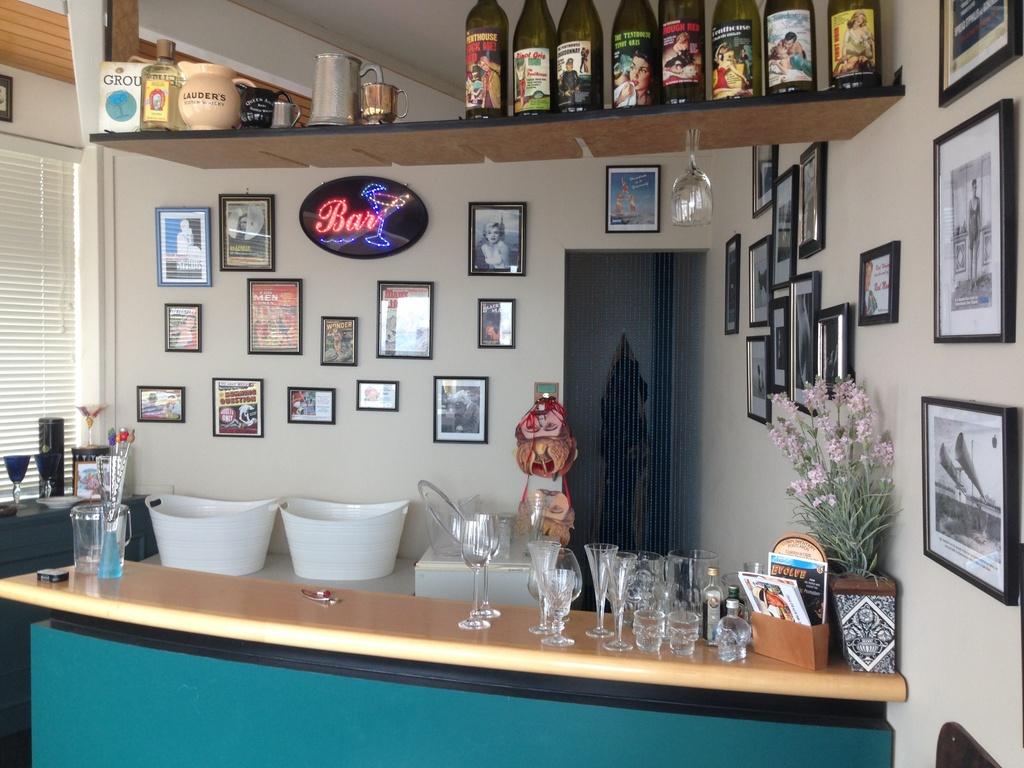What is the word displayed in the neon lights sign?
Provide a short and direct response. Bar. 